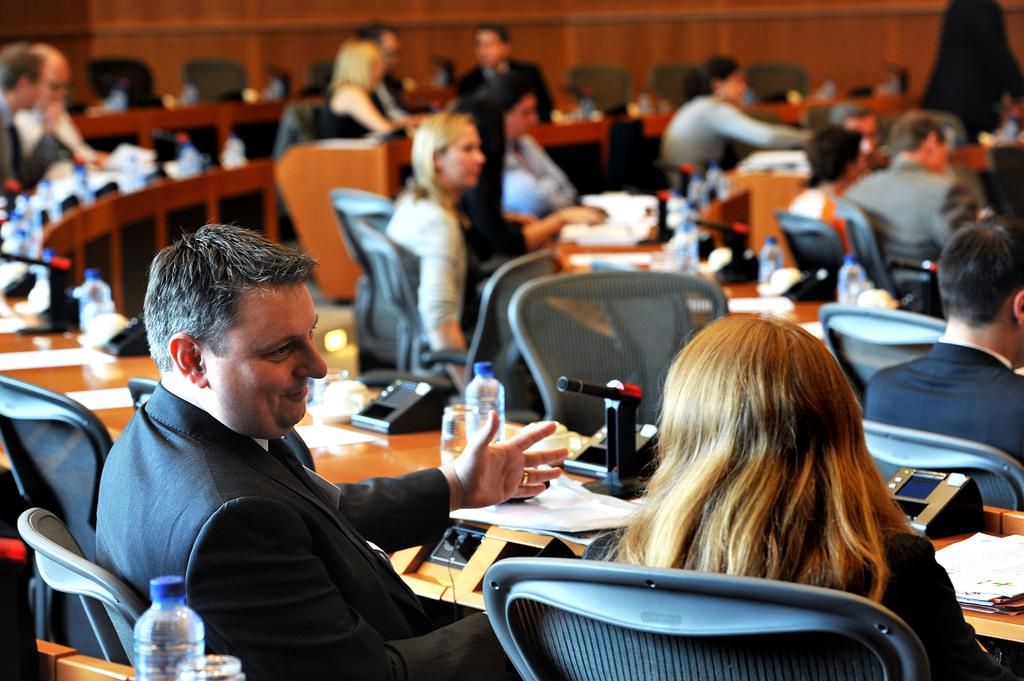How many people are sitting on the chair in the image? There are two persons sitting on a chair in the image. What are the two persons doing in the image? The two persons are having a conversation in the image. Are there any other people sitting on the chair in the image? Yes, there is a group of people sitting on the chair in the image. What color is the orange that the fly is sitting on in the image? There is no orange or fly present in the image. How many elbows can be seen in the image? The number of elbows cannot be determined from the provided facts, as the focus is on the number of people and their actions. 